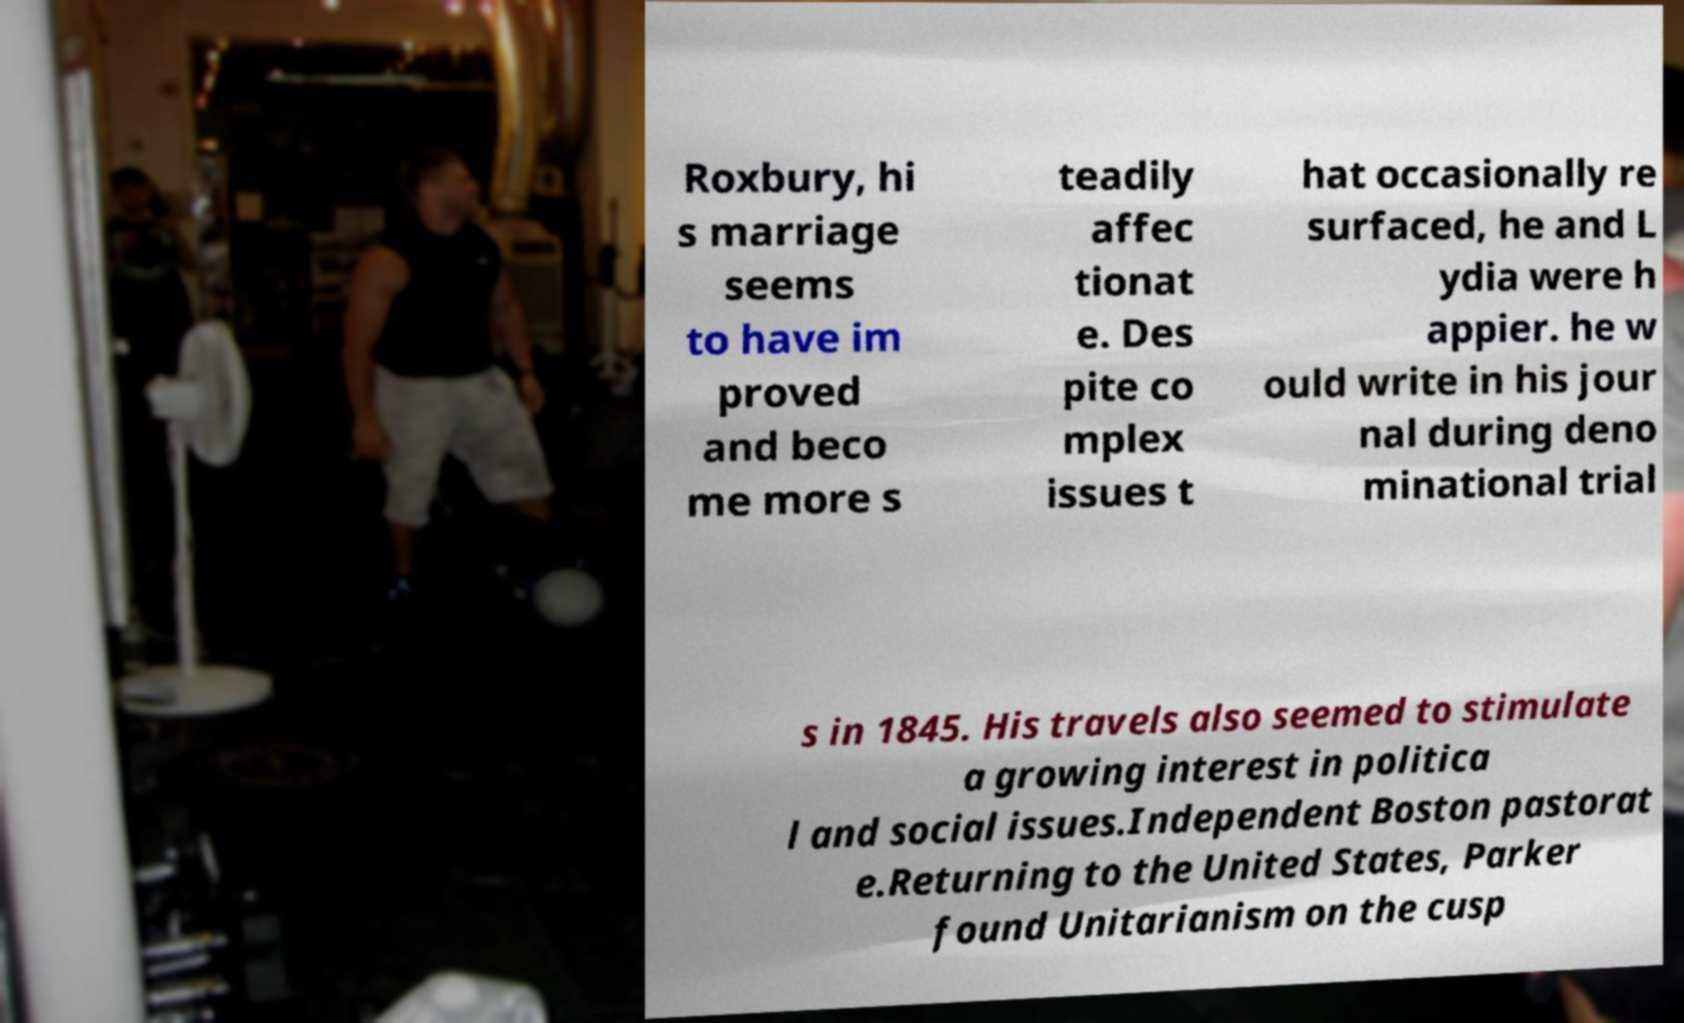Could you extract and type out the text from this image? Roxbury, hi s marriage seems to have im proved and beco me more s teadily affec tionat e. Des pite co mplex issues t hat occasionally re surfaced, he and L ydia were h appier. he w ould write in his jour nal during deno minational trial s in 1845. His travels also seemed to stimulate a growing interest in politica l and social issues.Independent Boston pastorat e.Returning to the United States, Parker found Unitarianism on the cusp 